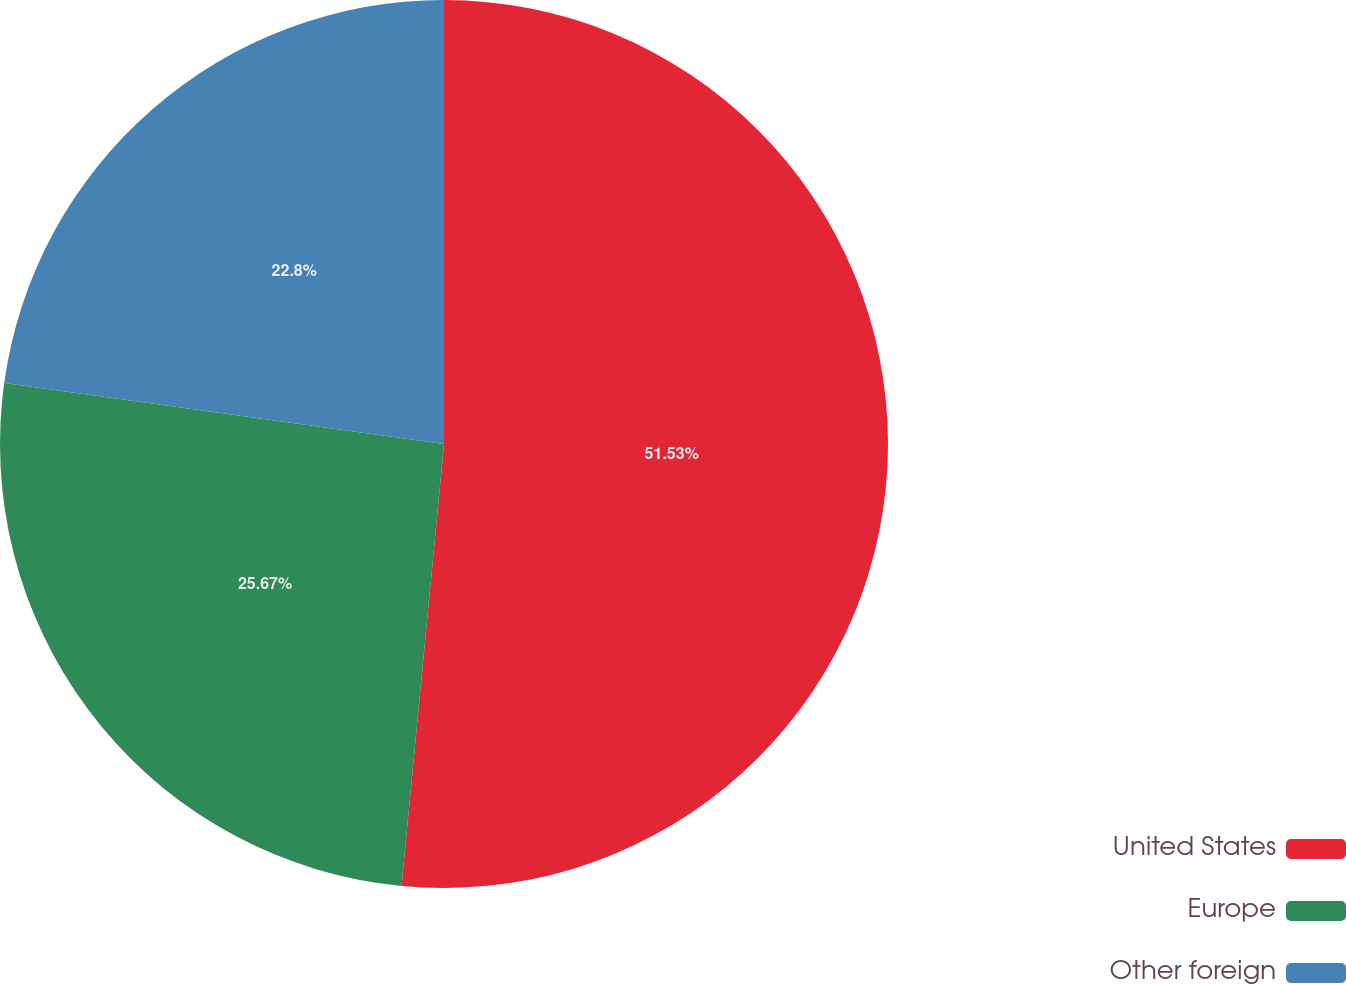Convert chart to OTSL. <chart><loc_0><loc_0><loc_500><loc_500><pie_chart><fcel>United States<fcel>Europe<fcel>Other foreign<nl><fcel>51.52%<fcel>25.67%<fcel>22.8%<nl></chart> 